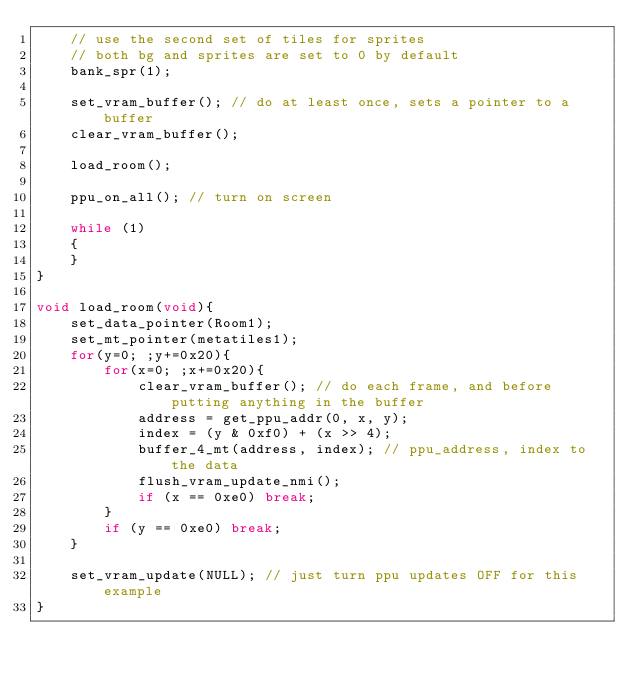Convert code to text. <code><loc_0><loc_0><loc_500><loc_500><_C_>	// use the second set of tiles for sprites
	// both bg and sprites are set to 0 by default
	bank_spr(1);

	set_vram_buffer(); // do at least once, sets a pointer to a buffer
	clear_vram_buffer();

	load_room();
	
	ppu_on_all(); // turn on screen
	
	while (1)
    {
    }
}

void load_room(void){
	set_data_pointer(Room1);
	set_mt_pointer(metatiles1);
	for(y=0; ;y+=0x20){
		for(x=0; ;x+=0x20){
			clear_vram_buffer(); // do each frame, and before putting anything in the buffer
			address = get_ppu_addr(0, x, y);
			index = (y & 0xf0) + (x >> 4);
			buffer_4_mt(address, index); // ppu_address, index to the data
			flush_vram_update_nmi();
			if (x == 0xe0) break;
		}
		if (y == 0xe0) break;
	}
	
	set_vram_update(NULL); // just turn ppu updates OFF for this example
}

</code> 